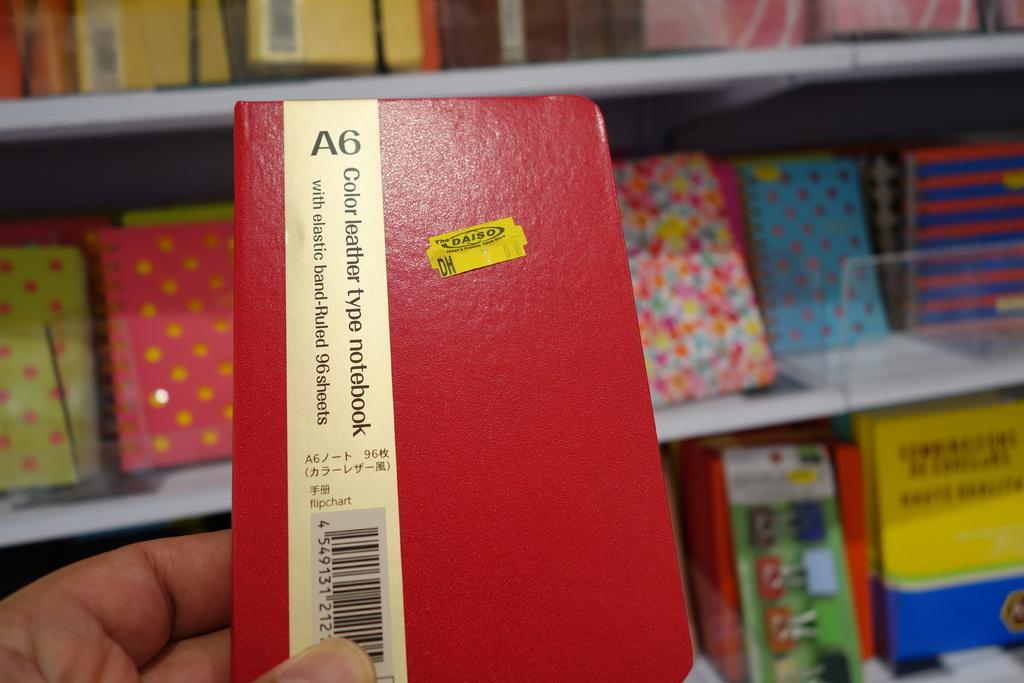<image>
Present a compact description of the photo's key features. a person holding a red notebook with a yellow Daiso sticker on it 